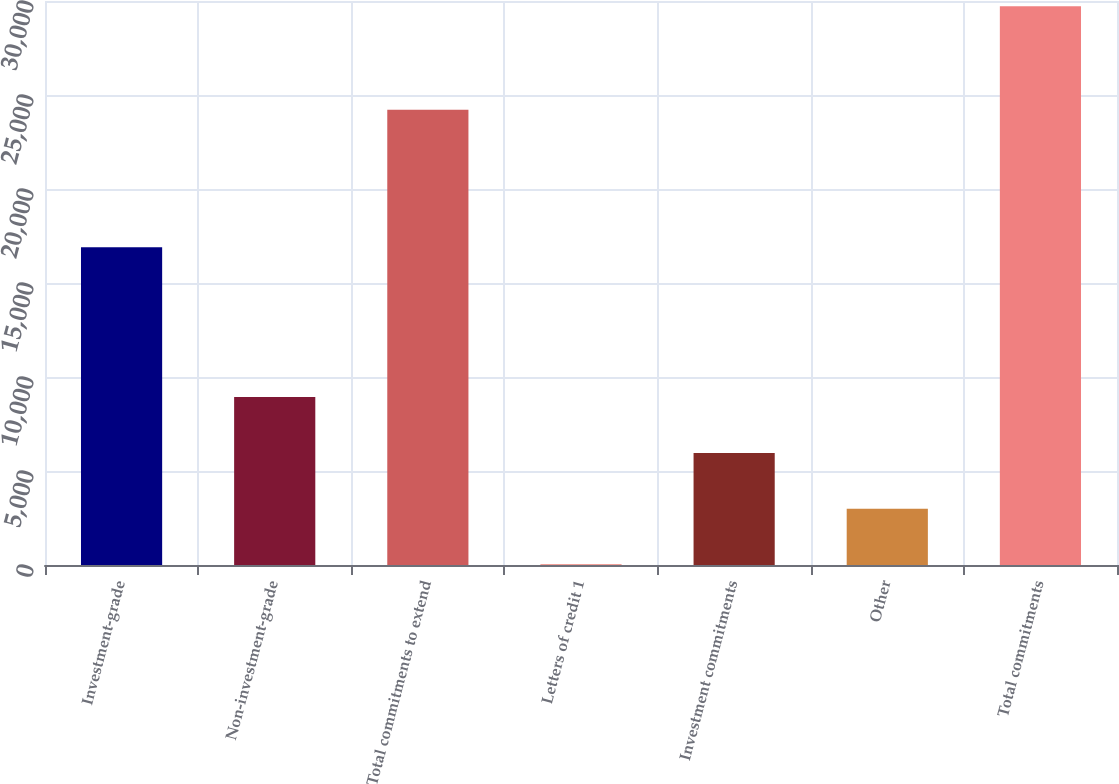<chart> <loc_0><loc_0><loc_500><loc_500><bar_chart><fcel>Investment-grade<fcel>Non-investment-grade<fcel>Total commitments to extend<fcel>Letters of credit 1<fcel>Investment commitments<fcel>Other<fcel>Total commitments<nl><fcel>16903<fcel>8931.9<fcel>24214<fcel>21<fcel>5961.6<fcel>2991.3<fcel>29724<nl></chart> 